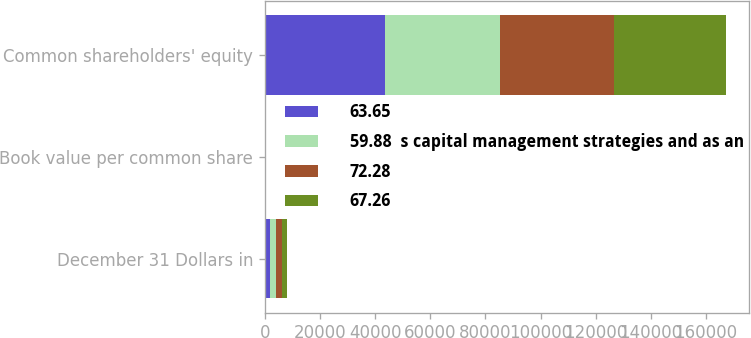Convert chart. <chart><loc_0><loc_0><loc_500><loc_500><stacked_bar_chart><ecel><fcel>December 31 Dollars in<fcel>Book value per common share<fcel>Common shareholders' equity<nl><fcel>63.65<fcel>2017<fcel>91.94<fcel>43530<nl><fcel>59.88  s capital management strategies and as an<fcel>2016<fcel>85.94<fcel>41723<nl><fcel>72.28<fcel>2015<fcel>81.84<fcel>41258<nl><fcel>67.26<fcel>2014<fcel>77.61<fcel>40605<nl></chart> 